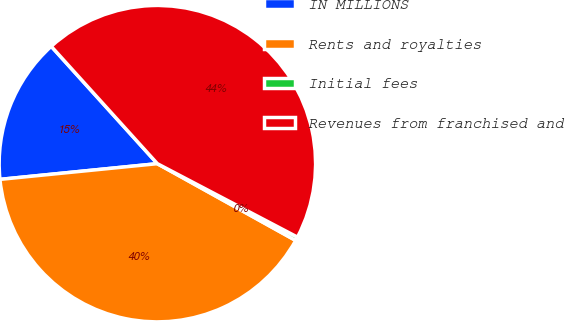Convert chart to OTSL. <chart><loc_0><loc_0><loc_500><loc_500><pie_chart><fcel>IN MILLIONS<fcel>Rents and royalties<fcel>Initial fees<fcel>Revenues from franchised and<nl><fcel>14.88%<fcel>40.35%<fcel>0.38%<fcel>44.39%<nl></chart> 